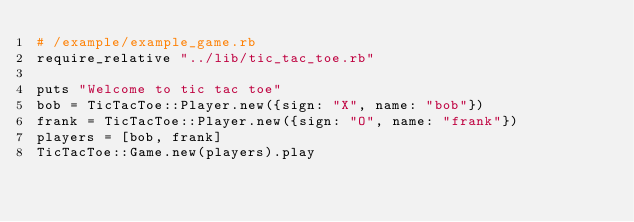<code> <loc_0><loc_0><loc_500><loc_500><_Ruby_># /example/example_game.rb
require_relative "../lib/tic_tac_toe.rb"
 
puts "Welcome to tic tac toe"
bob = TicTacToe::Player.new({sign: "X", name: "bob"})
frank = TicTacToe::Player.new({sign: "O", name: "frank"})
players = [bob, frank]
TicTacToe::Game.new(players).play</code> 